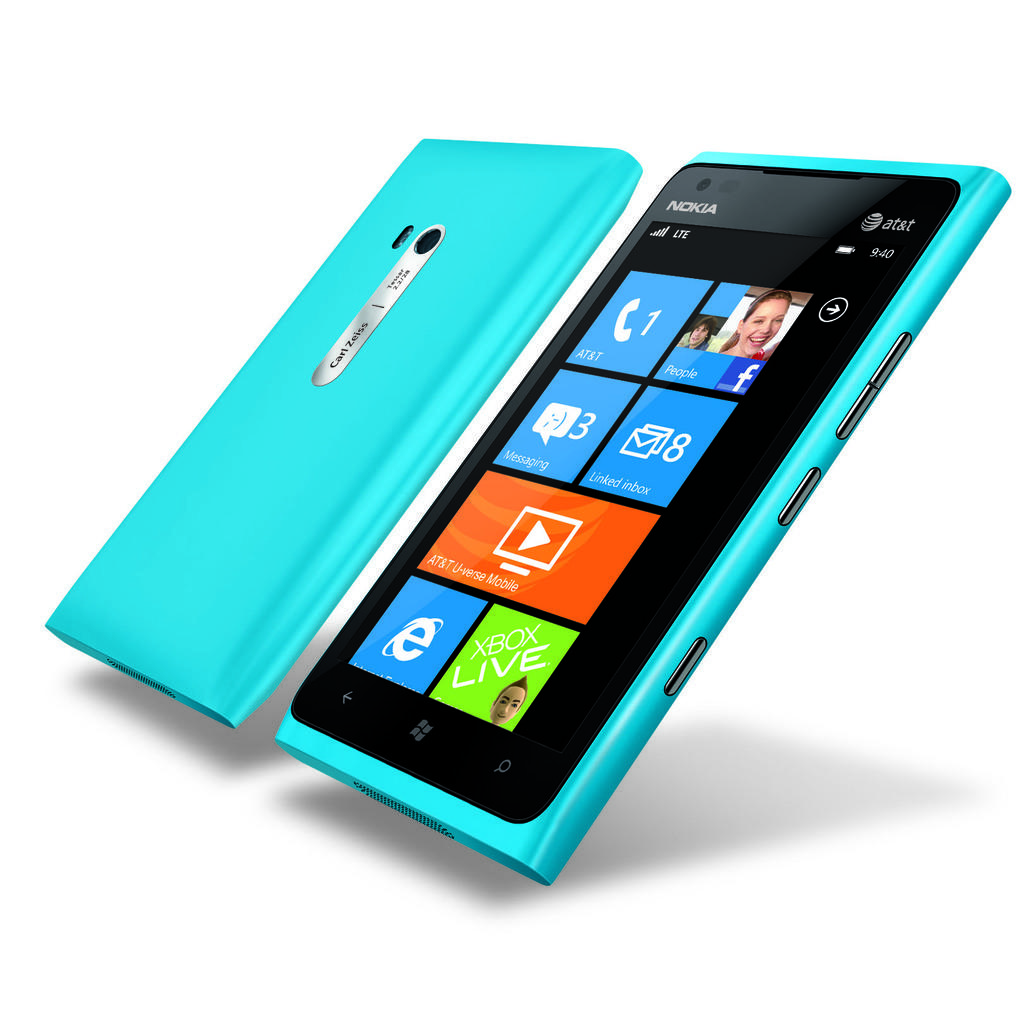What type of mobile phones are in the image? There are two Nokia Android mobile phones in the image. What color are the mobile phones? The mobile phones are blue in color. What is the color of the background in the image? The background of the image is white. Where might the image have been taken? The image may have been taken in a shop. Can you see a lake in the background of the image? No, there is no lake visible in the image; the background is white. 